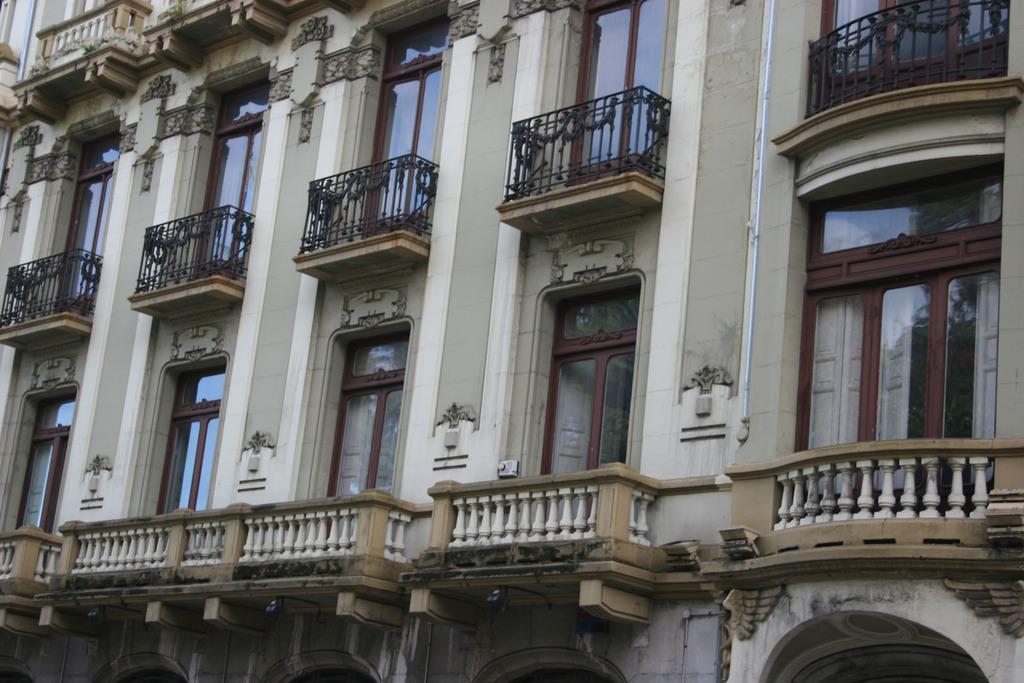Please provide a concise description of this image. In this picture we can see a building, we can see railings and windows of this building. 